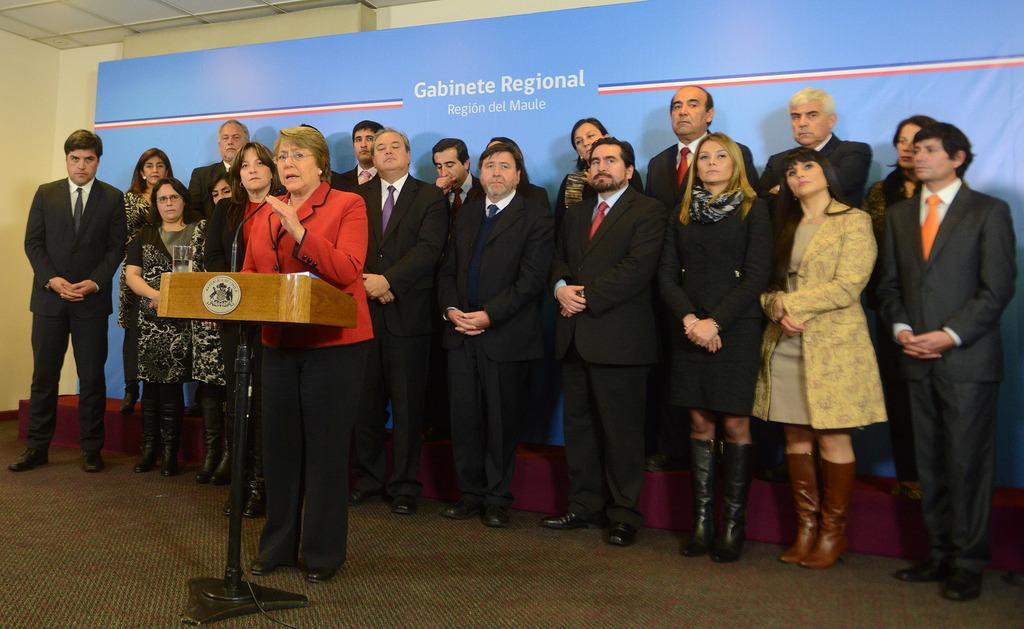Describe this image in one or two sentences. In this picture I can see a woman standing near the podium, there is a mike and a glass on the podium, there are group of people standing, and in the background there is a board and a wall. 